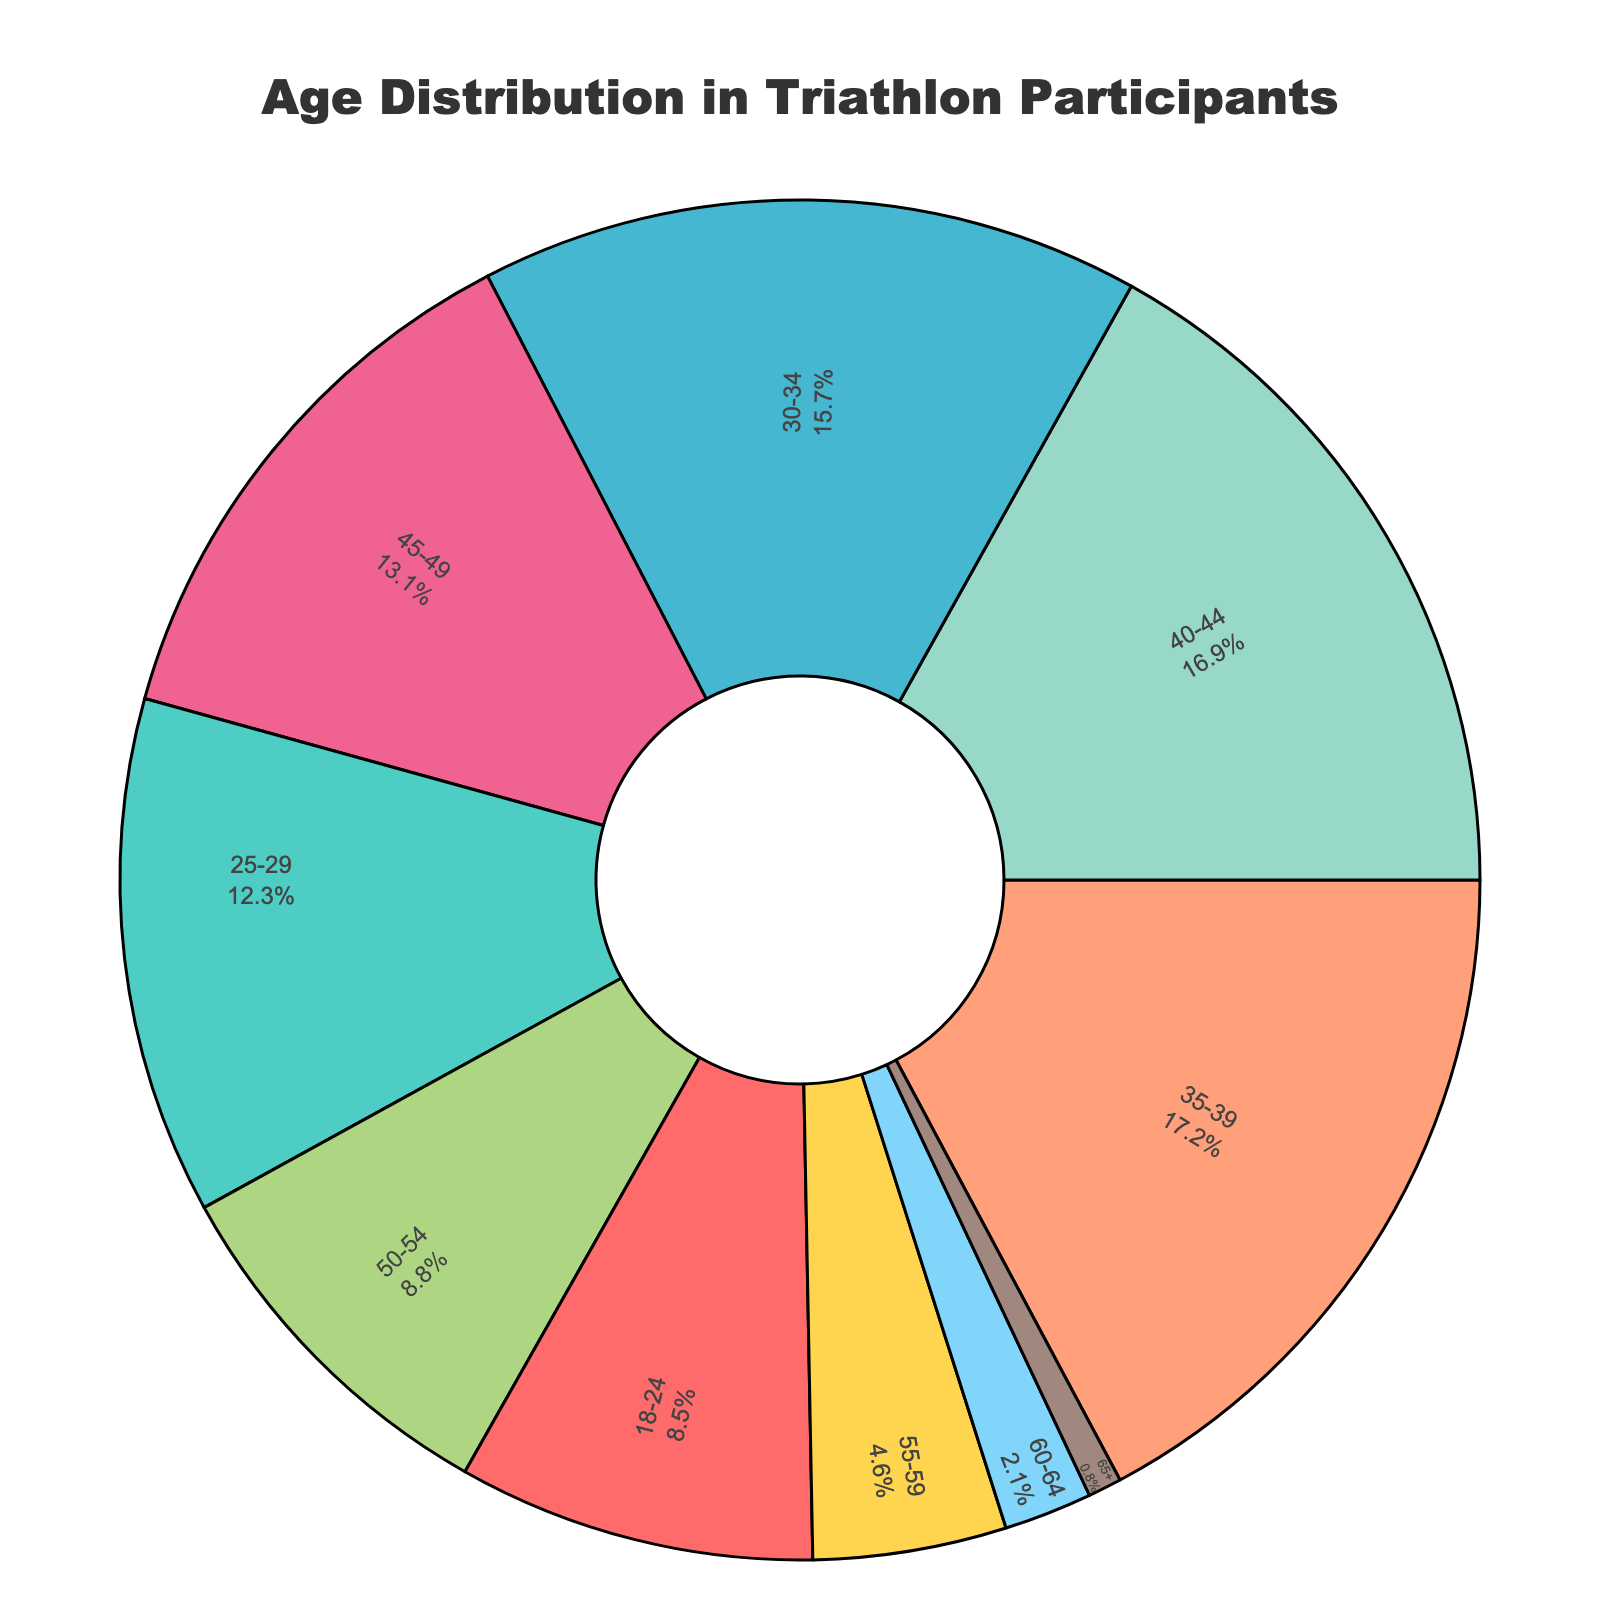What age group has the largest percentage of participants? Locate the age group with the highest percentage on the chart. Look at the segments and find "35-39".
Answer: 35-39 What is the total percentage of participants aged 45 and above? Add the percentages of the age groups 45-49, 50-54, 55-59, 60-64, and 65+. The sum is 13.1 + 8.8 + 4.6 + 2.1 + 0.8 = 29.4.
Answer: 29.4% Which age group has a percentage less than 5%? Identify the age groups with percentages smaller than 5%. These are "55-59" (4.6), "60-64" (2.1), and "65+" (0.8).
Answer: 55-59, 60-64, 65+ How does the percentage of participants aged 25-29 compare to those aged 50-54? Compare the percentages 12.3 (25-29) and 8.8 (50-54). 12.3% is greater than 8.8%.
Answer: 25-29 is greater What's the discrepancy in percentage between participants aged 30-34 and those aged 40-44? Subtract the percentage of 40-44 (16.9) from 30-34 (15.7). The result is 15.7 - 16.9 = -1.2.
Answer: -1.2% What is the cumulative percentage of the top three most represented age groups? Find the top three percentages: 35-39 (17.2), 40-44 (16.9), and 30-34 (15.7). Add them: 17.2 + 16.9 + 15.7 = 49.8.
Answer: 49.8% What percentage of participants is younger than 30? Add the percentages of age groups 18-24 and 25-29. The sum is 8.5 + 12.3 = 20.8.
Answer: 20.8% Compare the sum percentages of age groups 18-24 and 50+ to those aged 25-39? Sum percentages of 18-24 (8.5) and 50+ (8.8 + 4.6 + 2.1 + 0.8 = 16.3) to get 8.5 + 16.3 = 24.8. Sum percentages of 25-29, 30-34, 35-39 (12.3 + 15.7 + 17.2 = 45.2).
Answer: 24.8 is less than 45.2 What two age groups have a combined percentage closest to 30%? Consider combinations: 18-24 + 30-34 (8.5 + 15.7 = 24.2), 18-24 + 45-49 (8.5 + 13.1 = 21.6), 25-29 + 35-39 (12.3 + 17.2 = 29.5). 25-29 and 35-39 sum to 29.5% which is closest to 30%.
Answer: 25-29 and 35-39 Based on the visual, which age group is represented by the darkest segment? Identify the segment with the darkest color which corresponds to "A1887F" in the code, matching age group 40-44.
Answer: 40-44 